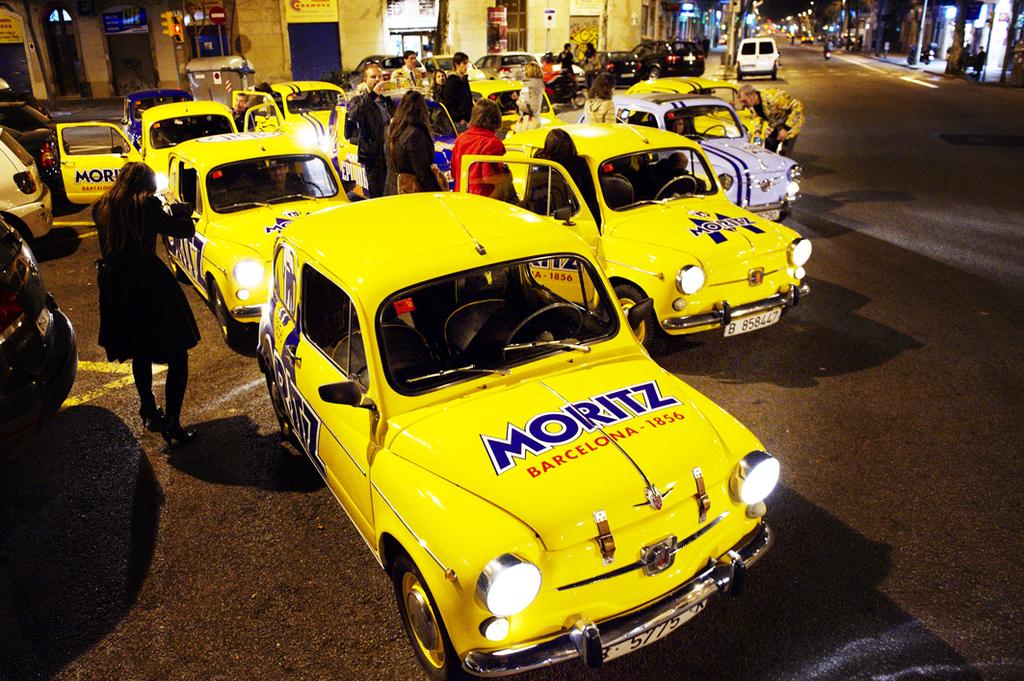What company is on the hood of the car?
Make the answer very short. Moritz. 